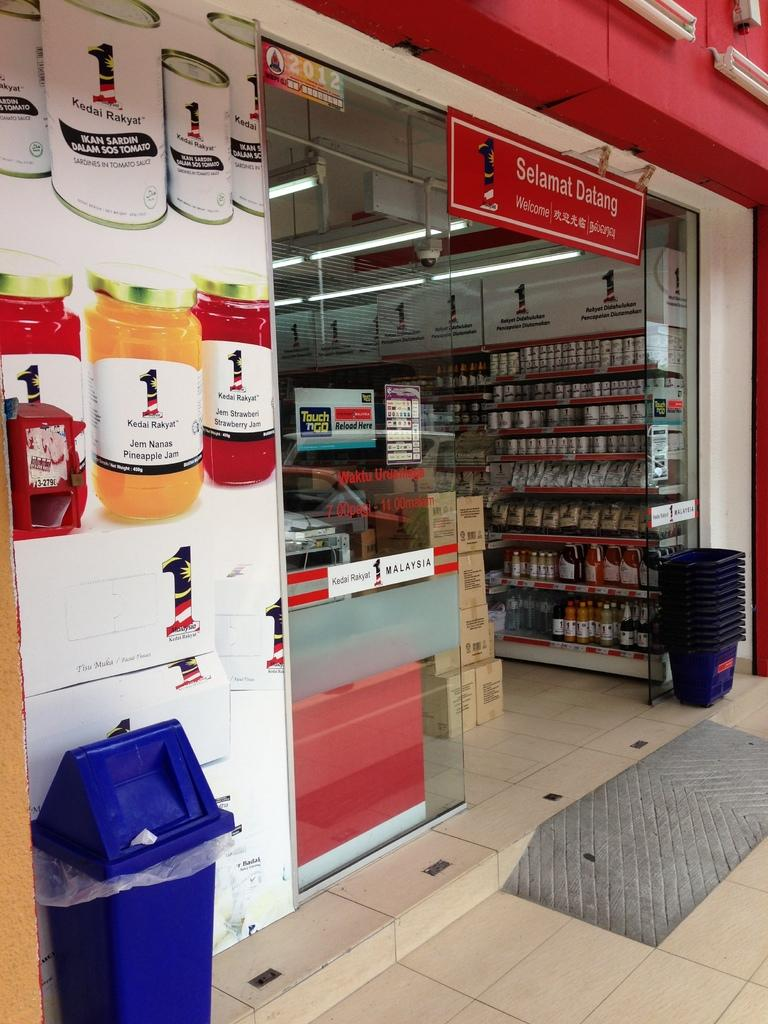<image>
Offer a succinct explanation of the picture presented. A red sign over a store entry says Selamat Datang. 